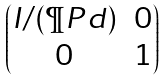<formula> <loc_0><loc_0><loc_500><loc_500>\begin{pmatrix} I / ( \P P d ) & 0 \\ 0 & 1 \end{pmatrix}</formula> 